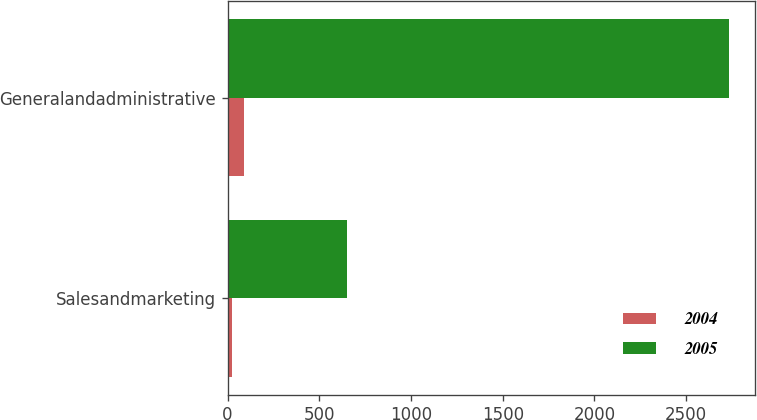<chart> <loc_0><loc_0><loc_500><loc_500><stacked_bar_chart><ecel><fcel>Salesandmarketing<fcel>Generalandadministrative<nl><fcel>2004<fcel>22<fcel>90<nl><fcel>2005<fcel>651<fcel>2736<nl></chart> 